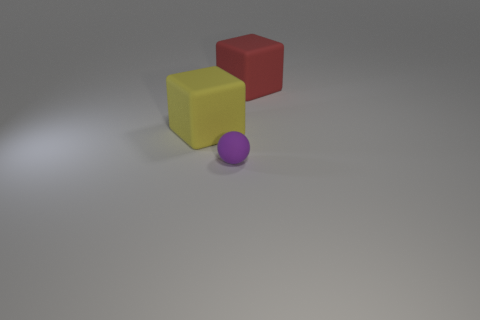Subtract 2 blocks. How many blocks are left? 0 Subtract all gray cylinders. Subtract all large yellow things. How many objects are left? 2 Add 1 red rubber cubes. How many red rubber cubes are left? 2 Add 1 small objects. How many small objects exist? 2 Add 2 large gray spheres. How many objects exist? 5 Subtract all red cubes. How many cubes are left? 1 Subtract 0 red cylinders. How many objects are left? 3 Subtract all balls. How many objects are left? 2 Subtract all yellow cubes. Subtract all red spheres. How many cubes are left? 1 Subtract all gray spheres. How many red cubes are left? 1 